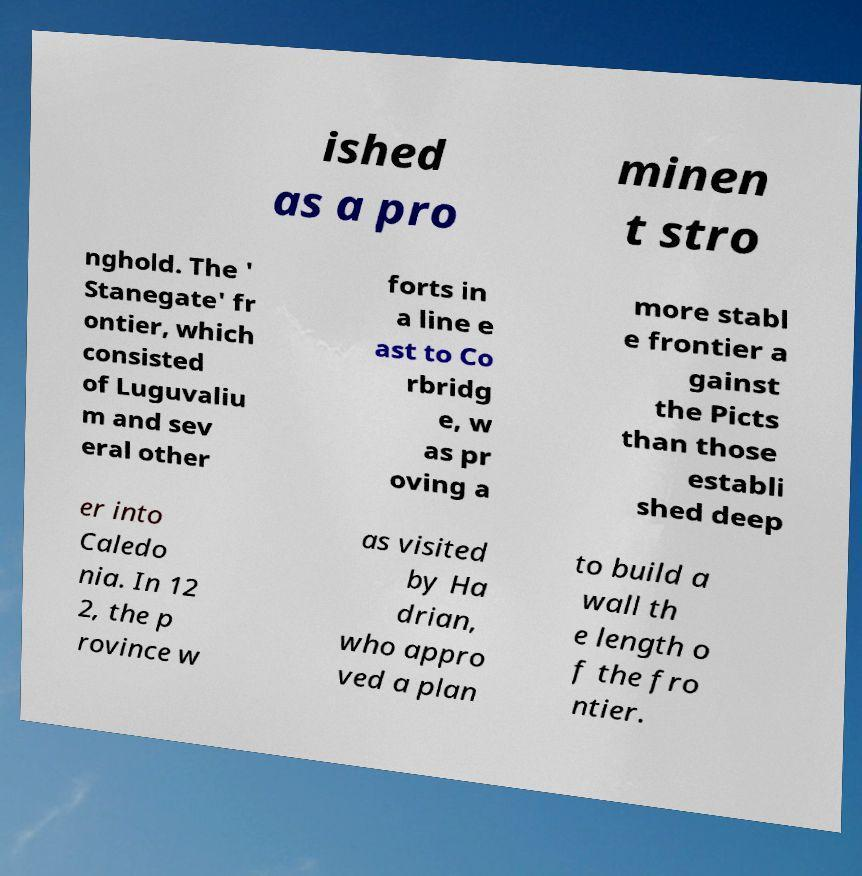Please read and relay the text visible in this image. What does it say? ished as a pro minen t stro nghold. The ' Stanegate' fr ontier, which consisted of Luguvaliu m and sev eral other forts in a line e ast to Co rbridg e, w as pr oving a more stabl e frontier a gainst the Picts than those establi shed deep er into Caledo nia. In 12 2, the p rovince w as visited by Ha drian, who appro ved a plan to build a wall th e length o f the fro ntier. 